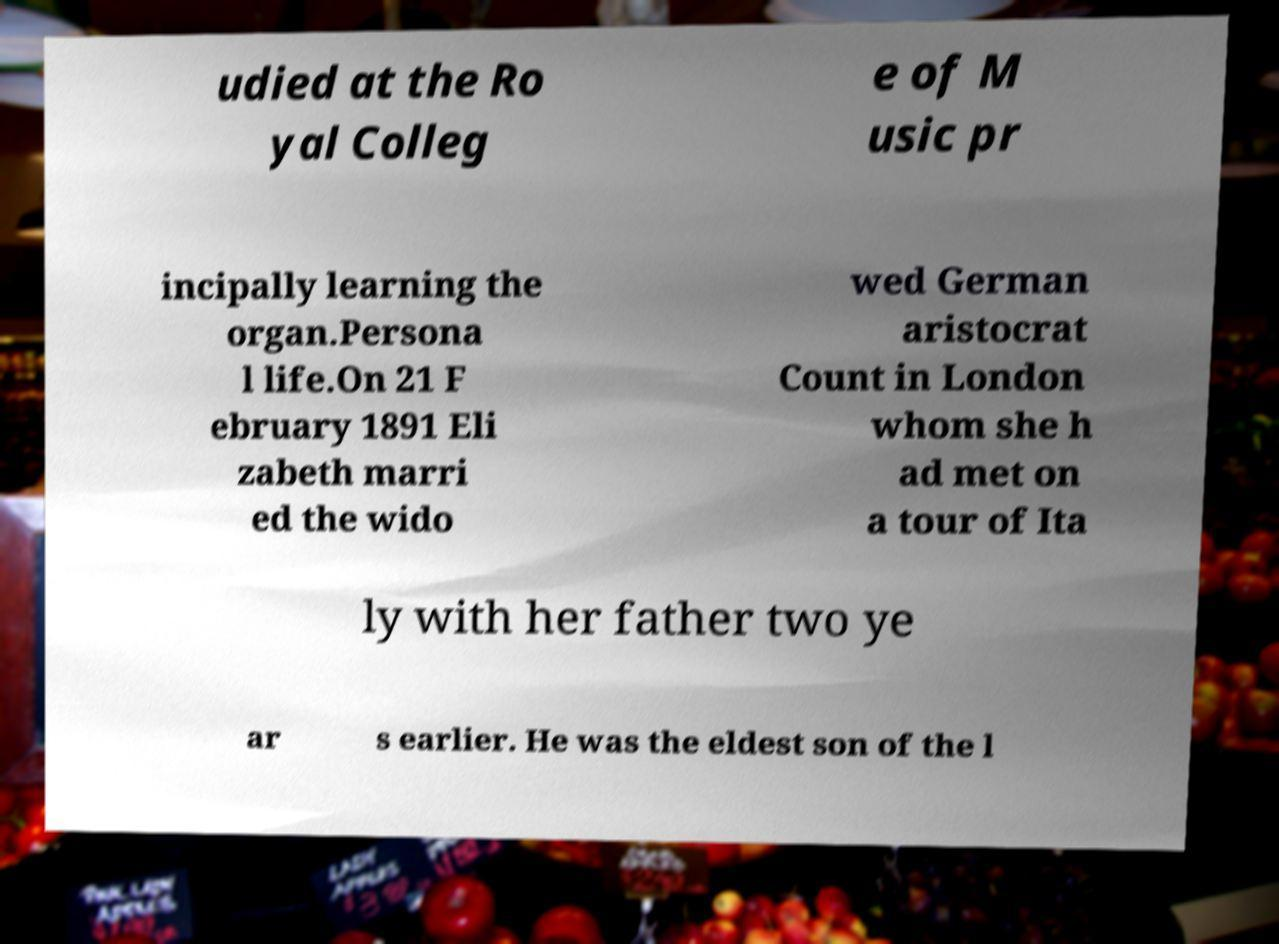There's text embedded in this image that I need extracted. Can you transcribe it verbatim? udied at the Ro yal Colleg e of M usic pr incipally learning the organ.Persona l life.On 21 F ebruary 1891 Eli zabeth marri ed the wido wed German aristocrat Count in London whom she h ad met on a tour of Ita ly with her father two ye ar s earlier. He was the eldest son of the l 